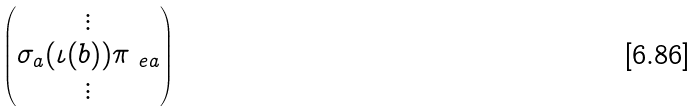<formula> <loc_0><loc_0><loc_500><loc_500>\begin{pmatrix} \vdots \\ \sigma _ { a } ( \iota ( b ) ) \pi _ { \ e a } \\ \vdots \end{pmatrix}</formula> 